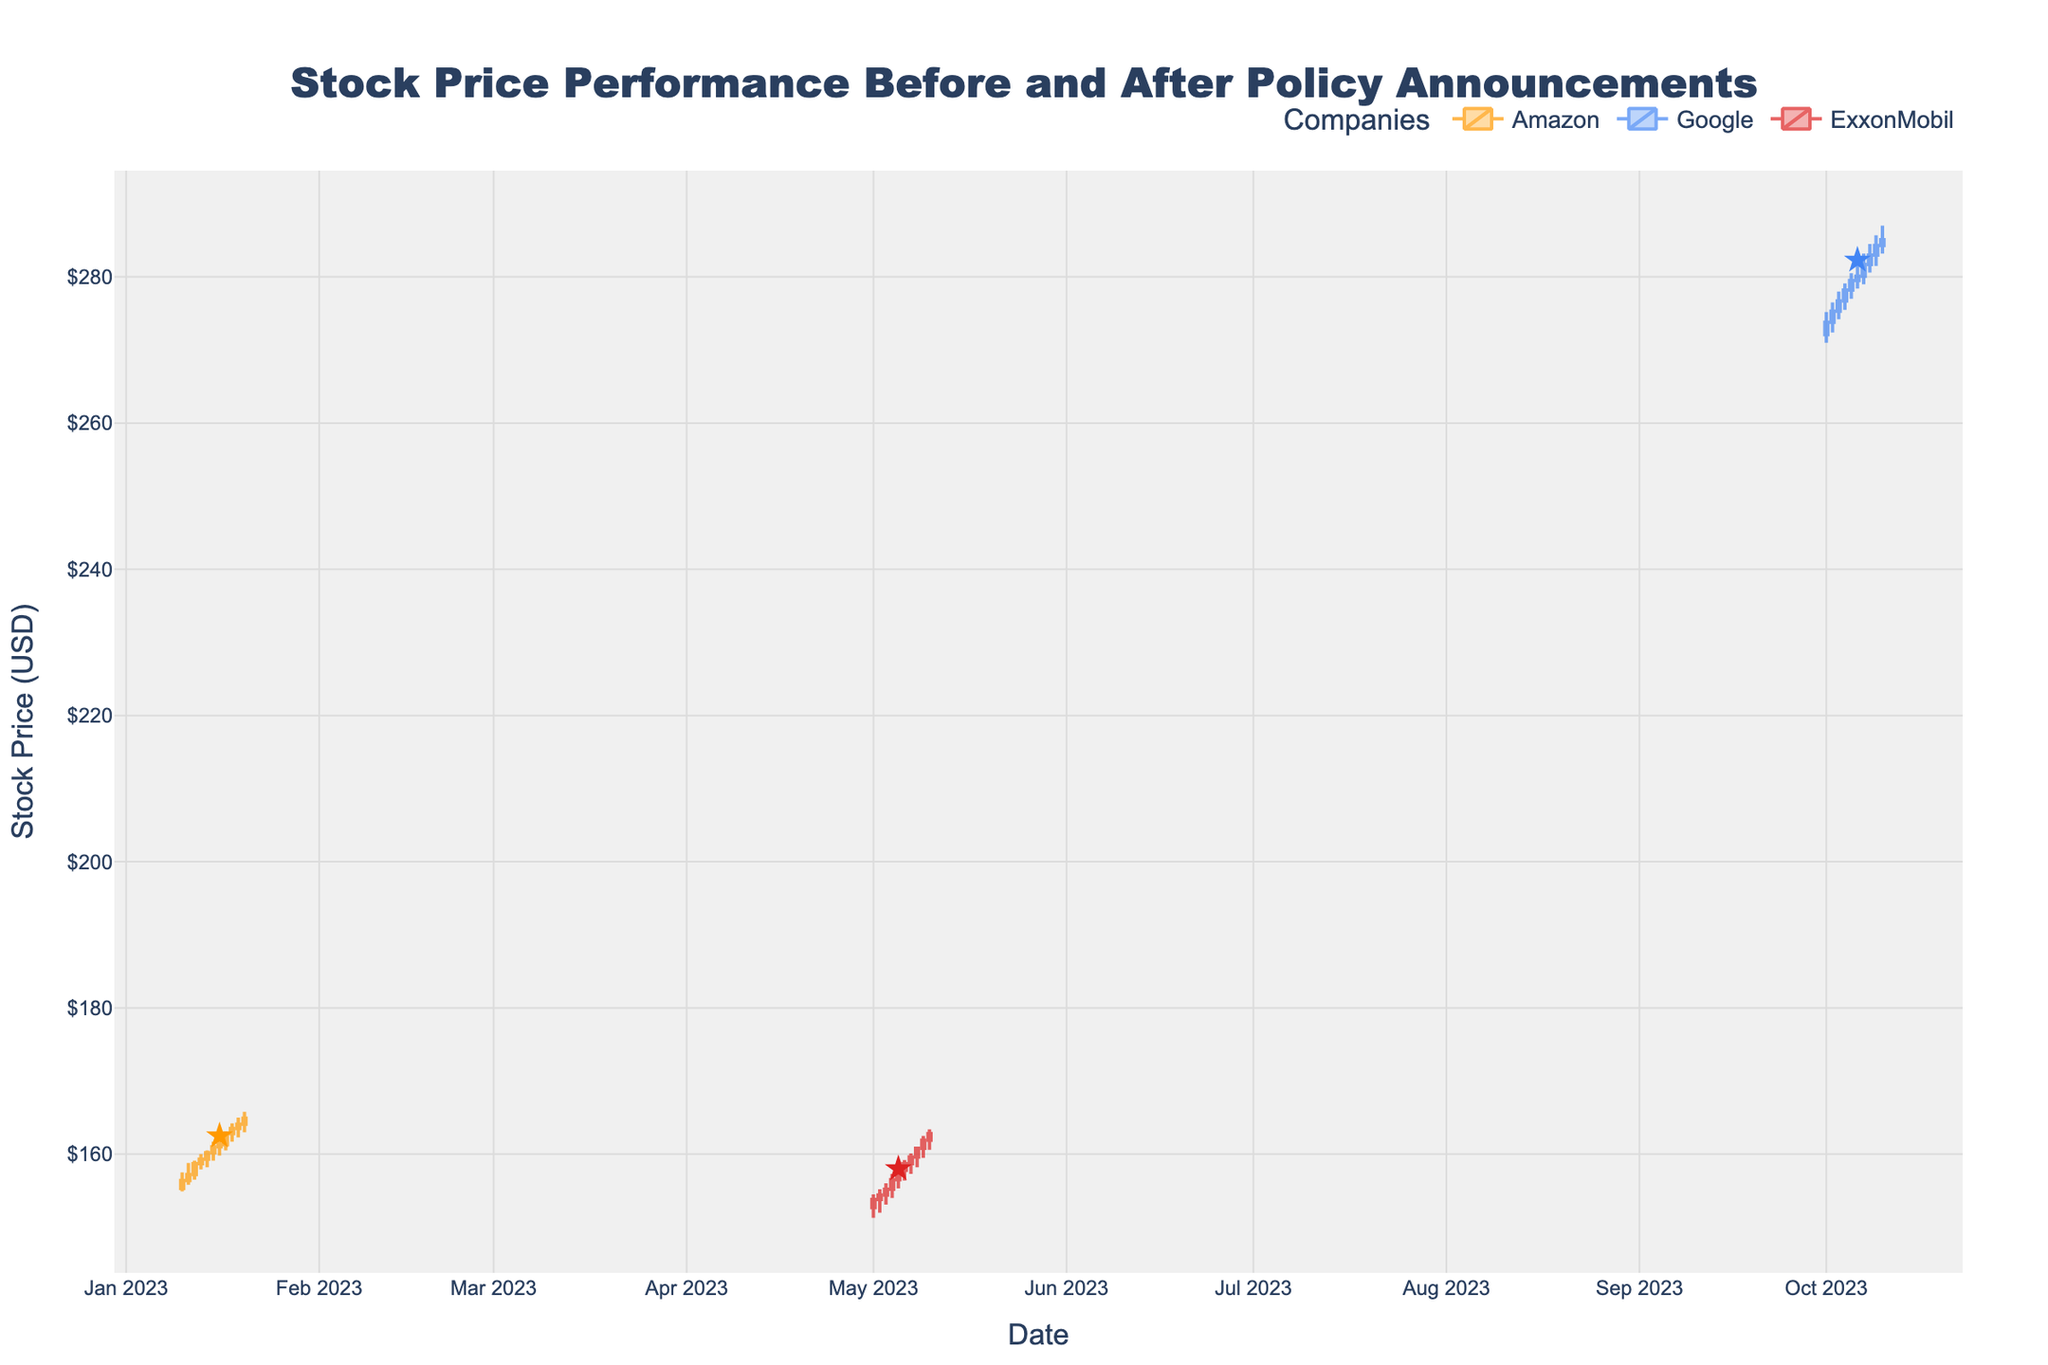What is the main title of the figure? The main title of the figure is located at the top center. It reads "Stock Price Performance Before and After Policy Announcements".
Answer: Stock Price Performance Before and After Policy Announcements How many companies' stock details are shown in the figure? The figure displays stock details for three companies. This information is drawn from the legend and the unique colors used for each company: Amazon, Google, and ExxonMobil.
Answer: Three What color represents Amazon's stock in the figure? The color representing Amazon's stock can be identified by looking at the candlestick traces and the associated legend. Amazon is shown in an orange color.
Answer: Orange Which company has the highest stock price after the policy announcement? To determine which company has the highest stock price after the policy announcement, locate the closing prices post-announcement for each company. Google has the highest prices post-announcement as indicated by the figure’s candlesticks.
Answer: Google On what date did Google's stock price reach its peak after the policy announcement? To find the peak, look at Google's candlesticks after the policy announcement. The highest value is observed on October 9, 2023.
Answer: October 9, 2023 For Amazon, compare the closing prices before and after the policy announcement. Was there an increase or decrease? Check Amazon's closing prices on January 15 (before) and January 16 (after). The closing price increased from 161.00 to 161.30. Therefore, there was an increase.
Answer: Increase What was the exact increase in closing price for ExxonMobil from the day before the policy announcement to the day after? To find the value, look at ExxonMobil’s closing price on May 4 (before) and May 5 (after). The increase is calculated as 157.80 - 156.50 = 1.30.
Answer: 1.30 Calculate the average closing price for Google after the policy announcement. Sum all closing prices for Google post-announcement and divide by the number of days. (280.10 + 281.70 + 283.00 + 284.30 + 285.10) / 5 = 1420.20 / 5 = 284.04
Answer: 284.04 Which company showed the largest volume of stocks traded after the policy announcement? Assess the volume bars visible after the policy announcement for each company. Google's stock traded the highest volume.
Answer: Google 